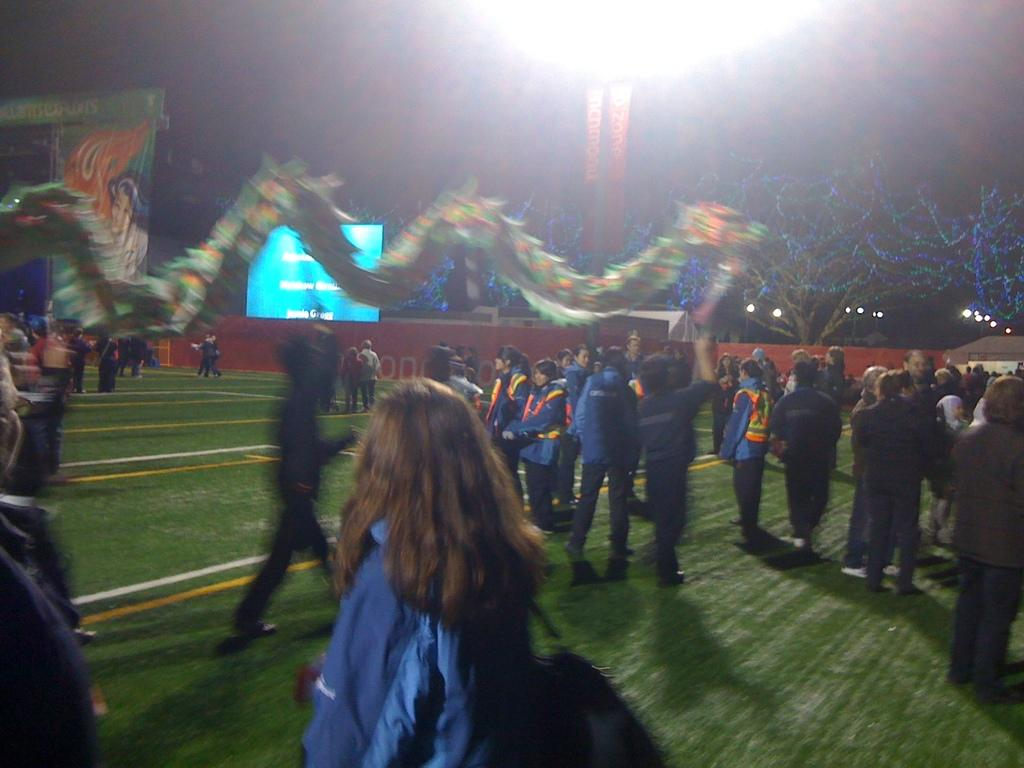What can be seen in the image? There are people standing in the image. What is at the bottom of the image? There is grass at the bottom of the image. What is in the background of the image? There is a screen in the background of the image. What is on the right side of the image? There is a tree on the right side of the image. What is visible in the image that provides light? There is a light visible in the image. What type of experience can be gained from wearing a mitten in the image? There is no mitten present in the image, so it is not possible to gain any experience from wearing one. 